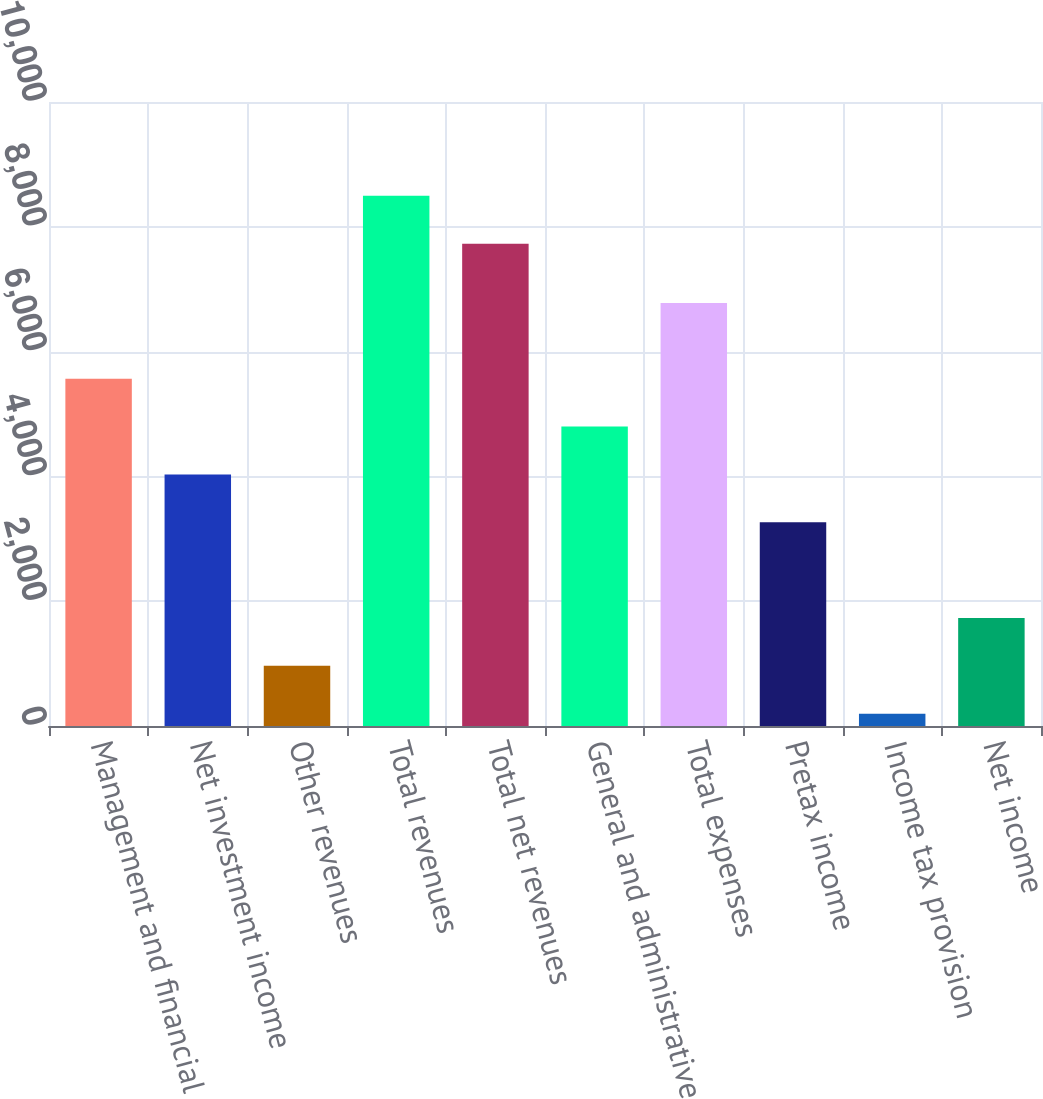Convert chart. <chart><loc_0><loc_0><loc_500><loc_500><bar_chart><fcel>Management and financial<fcel>Net investment income<fcel>Other revenues<fcel>Total revenues<fcel>Total net revenues<fcel>General and administrative<fcel>Total expenses<fcel>Pretax income<fcel>Income tax provision<fcel>Net income<nl><fcel>5564.9<fcel>4031.5<fcel>964.7<fcel>8496.7<fcel>7730<fcel>4798.2<fcel>6780<fcel>3264.8<fcel>198<fcel>1731.4<nl></chart> 